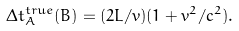<formula> <loc_0><loc_0><loc_500><loc_500>\Delta t _ { A } ^ { t r u e } ( B ) = ( { 2 L } / { v } ) ( 1 + { v ^ { 2 } } / { c ^ { 2 } } ) .</formula> 